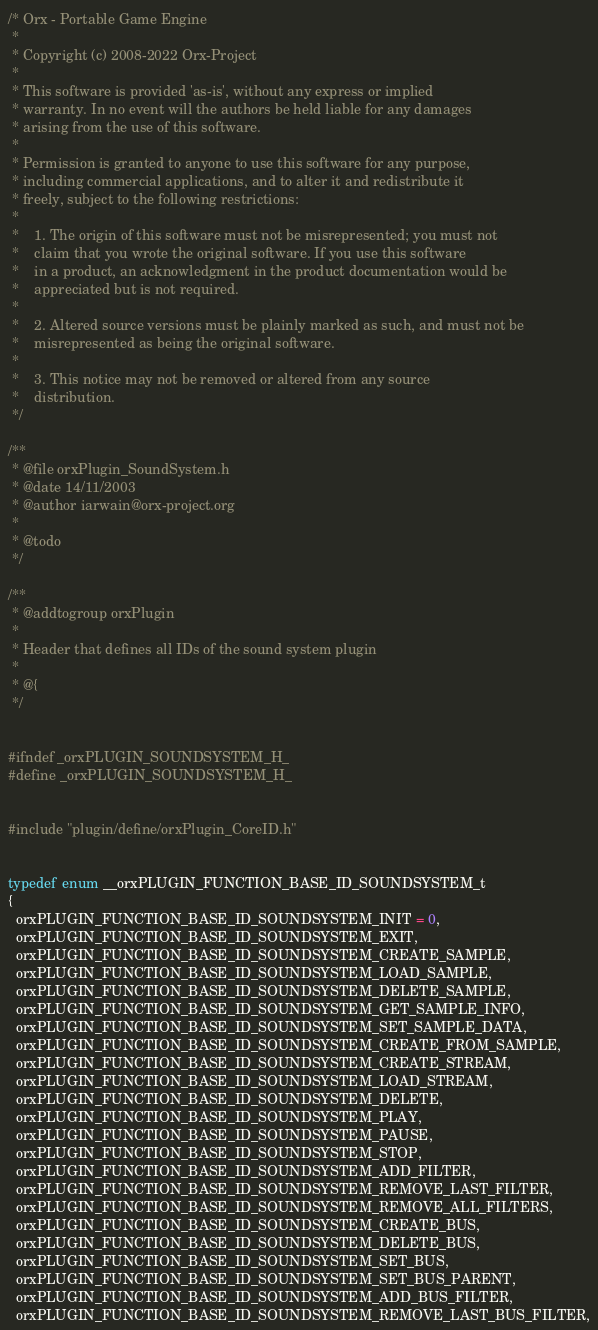Convert code to text. <code><loc_0><loc_0><loc_500><loc_500><_C_>/* Orx - Portable Game Engine
 *
 * Copyright (c) 2008-2022 Orx-Project
 *
 * This software is provided 'as-is', without any express or implied
 * warranty. In no event will the authors be held liable for any damages
 * arising from the use of this software.
 *
 * Permission is granted to anyone to use this software for any purpose,
 * including commercial applications, and to alter it and redistribute it
 * freely, subject to the following restrictions:
 *
 *    1. The origin of this software must not be misrepresented; you must not
 *    claim that you wrote the original software. If you use this software
 *    in a product, an acknowledgment in the product documentation would be
 *    appreciated but is not required.
 *
 *    2. Altered source versions must be plainly marked as such, and must not be
 *    misrepresented as being the original software.
 *
 *    3. This notice may not be removed or altered from any source
 *    distribution.
 */

/**
 * @file orxPlugin_SoundSystem.h
 * @date 14/11/2003
 * @author iarwain@orx-project.org
 *
 * @todo
 */

/**
 * @addtogroup orxPlugin
 *
 * Header that defines all IDs of the sound system plugin
 *
 * @{
 */


#ifndef _orxPLUGIN_SOUNDSYSTEM_H_
#define _orxPLUGIN_SOUNDSYSTEM_H_


#include "plugin/define/orxPlugin_CoreID.h"


typedef enum __orxPLUGIN_FUNCTION_BASE_ID_SOUNDSYSTEM_t
{
  orxPLUGIN_FUNCTION_BASE_ID_SOUNDSYSTEM_INIT = 0,
  orxPLUGIN_FUNCTION_BASE_ID_SOUNDSYSTEM_EXIT,
  orxPLUGIN_FUNCTION_BASE_ID_SOUNDSYSTEM_CREATE_SAMPLE,
  orxPLUGIN_FUNCTION_BASE_ID_SOUNDSYSTEM_LOAD_SAMPLE,
  orxPLUGIN_FUNCTION_BASE_ID_SOUNDSYSTEM_DELETE_SAMPLE,
  orxPLUGIN_FUNCTION_BASE_ID_SOUNDSYSTEM_GET_SAMPLE_INFO,
  orxPLUGIN_FUNCTION_BASE_ID_SOUNDSYSTEM_SET_SAMPLE_DATA,
  orxPLUGIN_FUNCTION_BASE_ID_SOUNDSYSTEM_CREATE_FROM_SAMPLE,
  orxPLUGIN_FUNCTION_BASE_ID_SOUNDSYSTEM_CREATE_STREAM,
  orxPLUGIN_FUNCTION_BASE_ID_SOUNDSYSTEM_LOAD_STREAM,
  orxPLUGIN_FUNCTION_BASE_ID_SOUNDSYSTEM_DELETE,
  orxPLUGIN_FUNCTION_BASE_ID_SOUNDSYSTEM_PLAY,
  orxPLUGIN_FUNCTION_BASE_ID_SOUNDSYSTEM_PAUSE,
  orxPLUGIN_FUNCTION_BASE_ID_SOUNDSYSTEM_STOP,
  orxPLUGIN_FUNCTION_BASE_ID_SOUNDSYSTEM_ADD_FILTER,
  orxPLUGIN_FUNCTION_BASE_ID_SOUNDSYSTEM_REMOVE_LAST_FILTER,
  orxPLUGIN_FUNCTION_BASE_ID_SOUNDSYSTEM_REMOVE_ALL_FILTERS,
  orxPLUGIN_FUNCTION_BASE_ID_SOUNDSYSTEM_CREATE_BUS,
  orxPLUGIN_FUNCTION_BASE_ID_SOUNDSYSTEM_DELETE_BUS,
  orxPLUGIN_FUNCTION_BASE_ID_SOUNDSYSTEM_SET_BUS,
  orxPLUGIN_FUNCTION_BASE_ID_SOUNDSYSTEM_SET_BUS_PARENT,
  orxPLUGIN_FUNCTION_BASE_ID_SOUNDSYSTEM_ADD_BUS_FILTER,
  orxPLUGIN_FUNCTION_BASE_ID_SOUNDSYSTEM_REMOVE_LAST_BUS_FILTER,</code> 